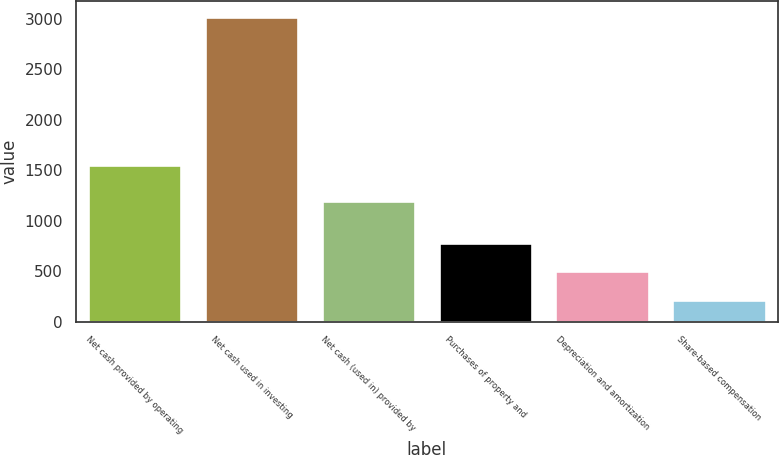Convert chart. <chart><loc_0><loc_0><loc_500><loc_500><bar_chart><fcel>Net cash provided by operating<fcel>Net cash used in investing<fcel>Net cash (used in) provided by<fcel>Purchases of property and<fcel>Depreciation and amortization<fcel>Share-based compensation<nl><fcel>1549<fcel>3023<fcel>1198<fcel>778.2<fcel>497.6<fcel>217<nl></chart> 